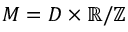Convert formula to latex. <formula><loc_0><loc_0><loc_500><loc_500>M = D \times \mathbb { R } / \mathbb { Z }</formula> 